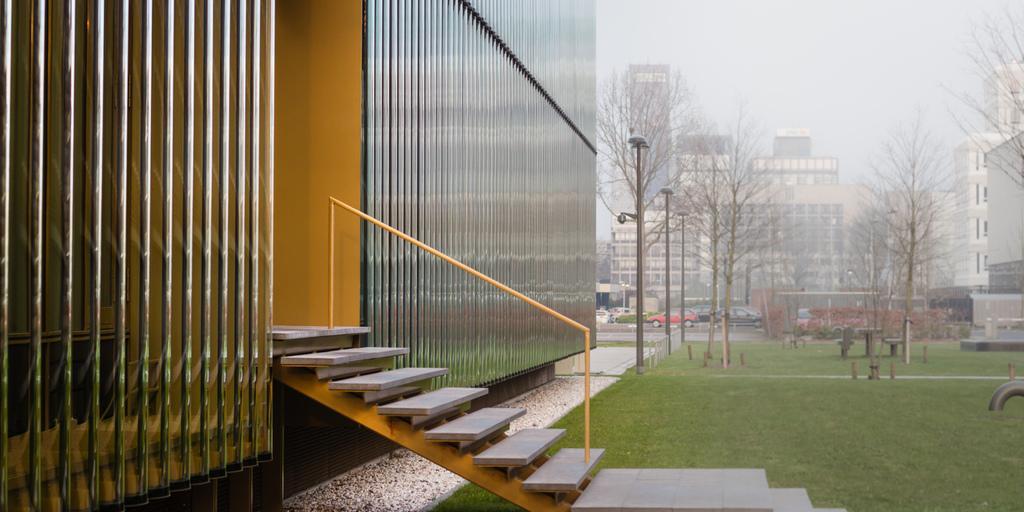Please provide a concise description of this image. In this picture I can see there is a building and there are some stairs and there is a railing here and grass. There are trees and buildings, the sky is clear. 